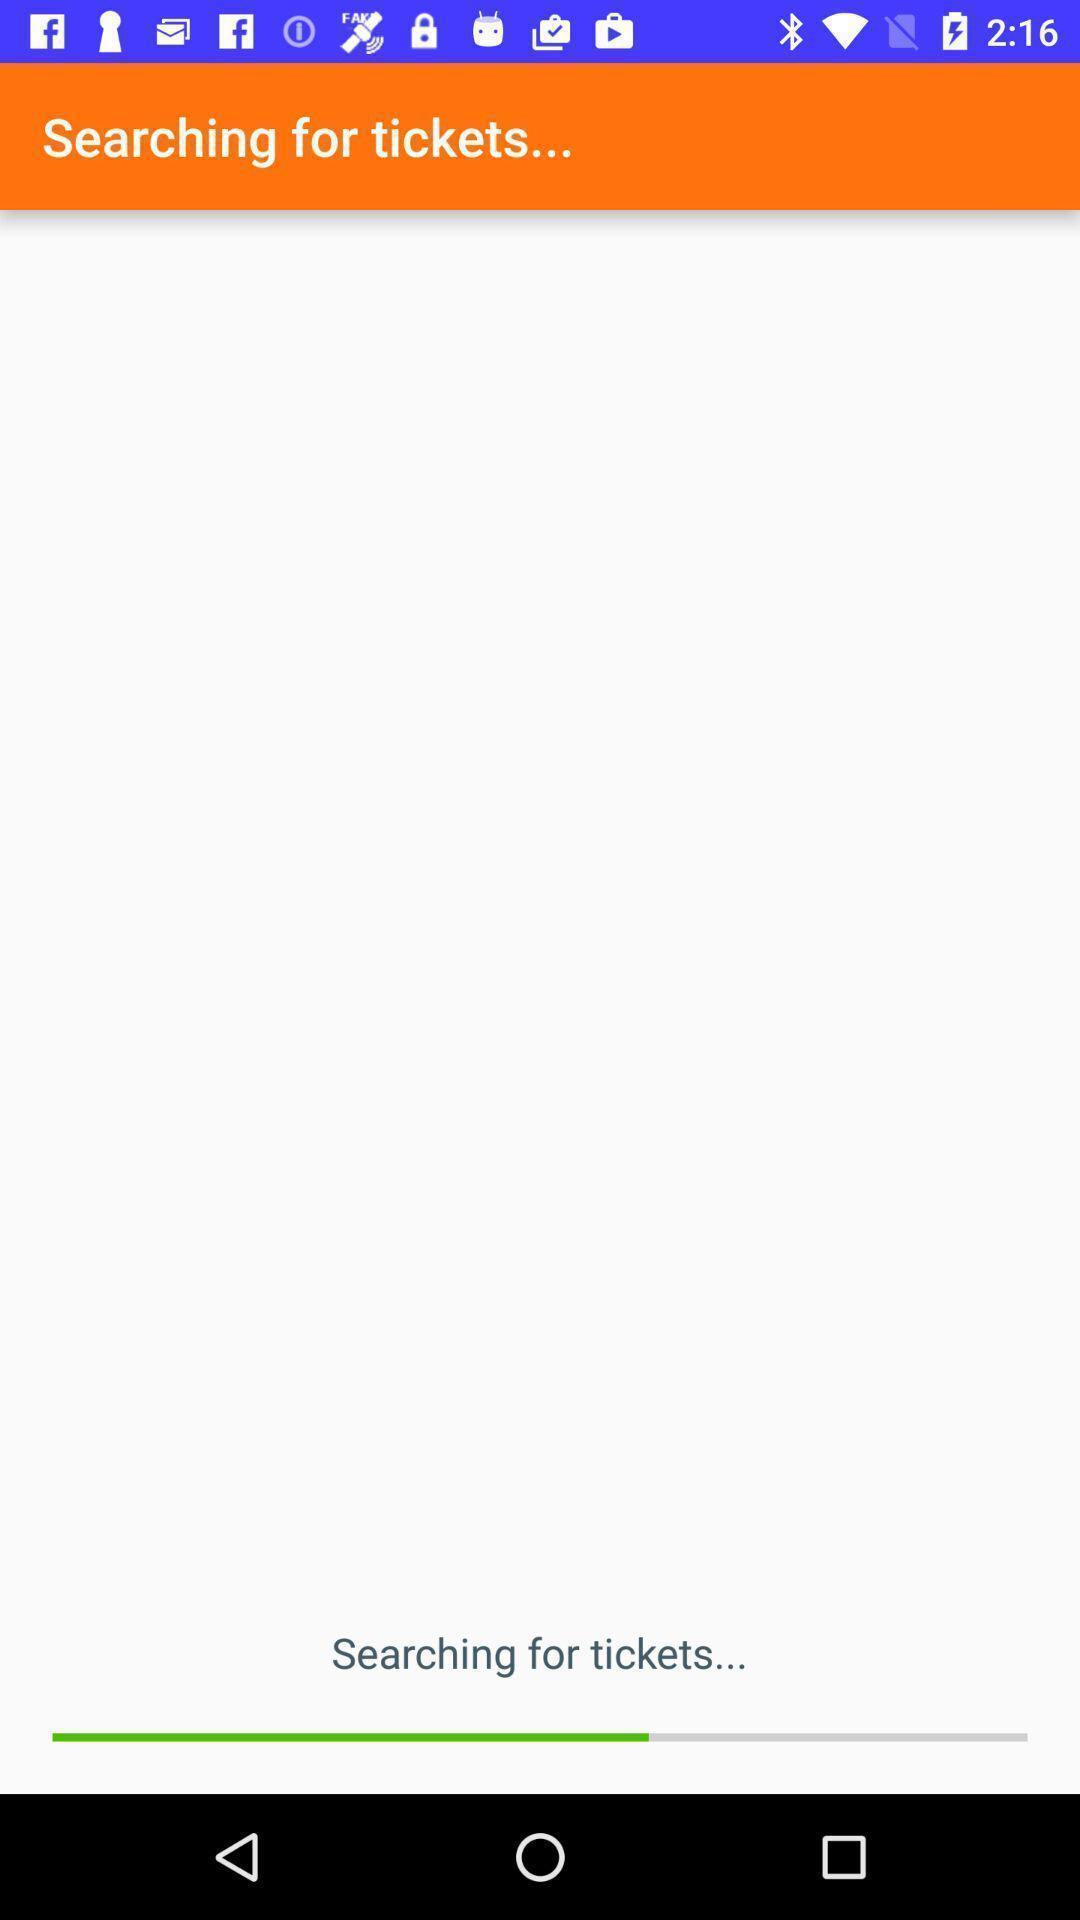What can you discern from this picture? Page showing searching for tickets. 